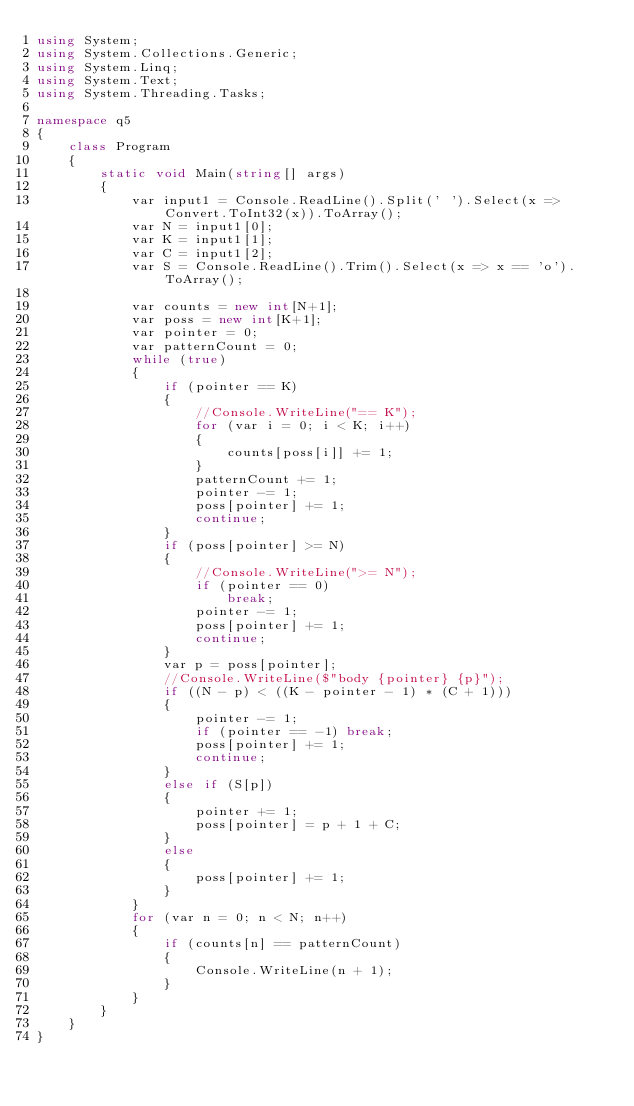<code> <loc_0><loc_0><loc_500><loc_500><_C#_>using System;
using System.Collections.Generic;
using System.Linq;
using System.Text;
using System.Threading.Tasks;

namespace q5
{
    class Program
    {
        static void Main(string[] args)
        {
            var input1 = Console.ReadLine().Split(' ').Select(x => Convert.ToInt32(x)).ToArray();
            var N = input1[0];
            var K = input1[1];
            var C = input1[2];
            var S = Console.ReadLine().Trim().Select(x => x == 'o').ToArray();

            var counts = new int[N+1];
            var poss = new int[K+1];
            var pointer = 0;
            var patternCount = 0;
            while (true)
            {
                if (pointer == K)
                {
                    //Console.WriteLine("== K");
                    for (var i = 0; i < K; i++)
                    {
                        counts[poss[i]] += 1;
                    }
                    patternCount += 1;
                    pointer -= 1;
                    poss[pointer] += 1;
                    continue;
                }
                if (poss[pointer] >= N)
                {
                    //Console.WriteLine(">= N");
                    if (pointer == 0)
                        break;
                    pointer -= 1;
                    poss[pointer] += 1;
                    continue;
                }
                var p = poss[pointer];
                //Console.WriteLine($"body {pointer} {p}");
                if ((N - p) < ((K - pointer - 1) * (C + 1)))
                {
                    pointer -= 1;
                    if (pointer == -1) break;
                    poss[pointer] += 1;
                    continue;
                }
                else if (S[p])
                {
                    pointer += 1;
                    poss[pointer] = p + 1 + C;
                }
                else
                {
                    poss[pointer] += 1;
                }
            }
            for (var n = 0; n < N; n++)
            {
                if (counts[n] == patternCount)
                {
                    Console.WriteLine(n + 1);
                }
            }
        }
    }
}
</code> 